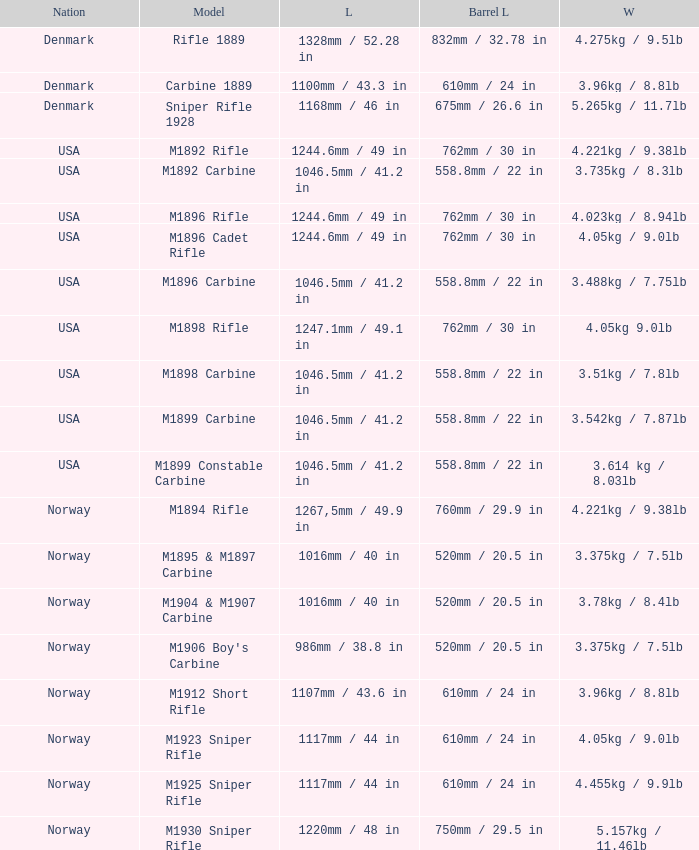What is Weight, when Length is 1168mm / 46 in? 5.265kg / 11.7lb. 